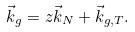Convert formula to latex. <formula><loc_0><loc_0><loc_500><loc_500>\vec { k } _ { g } = z \vec { k } _ { N } + \vec { k } _ { g , T } .</formula> 